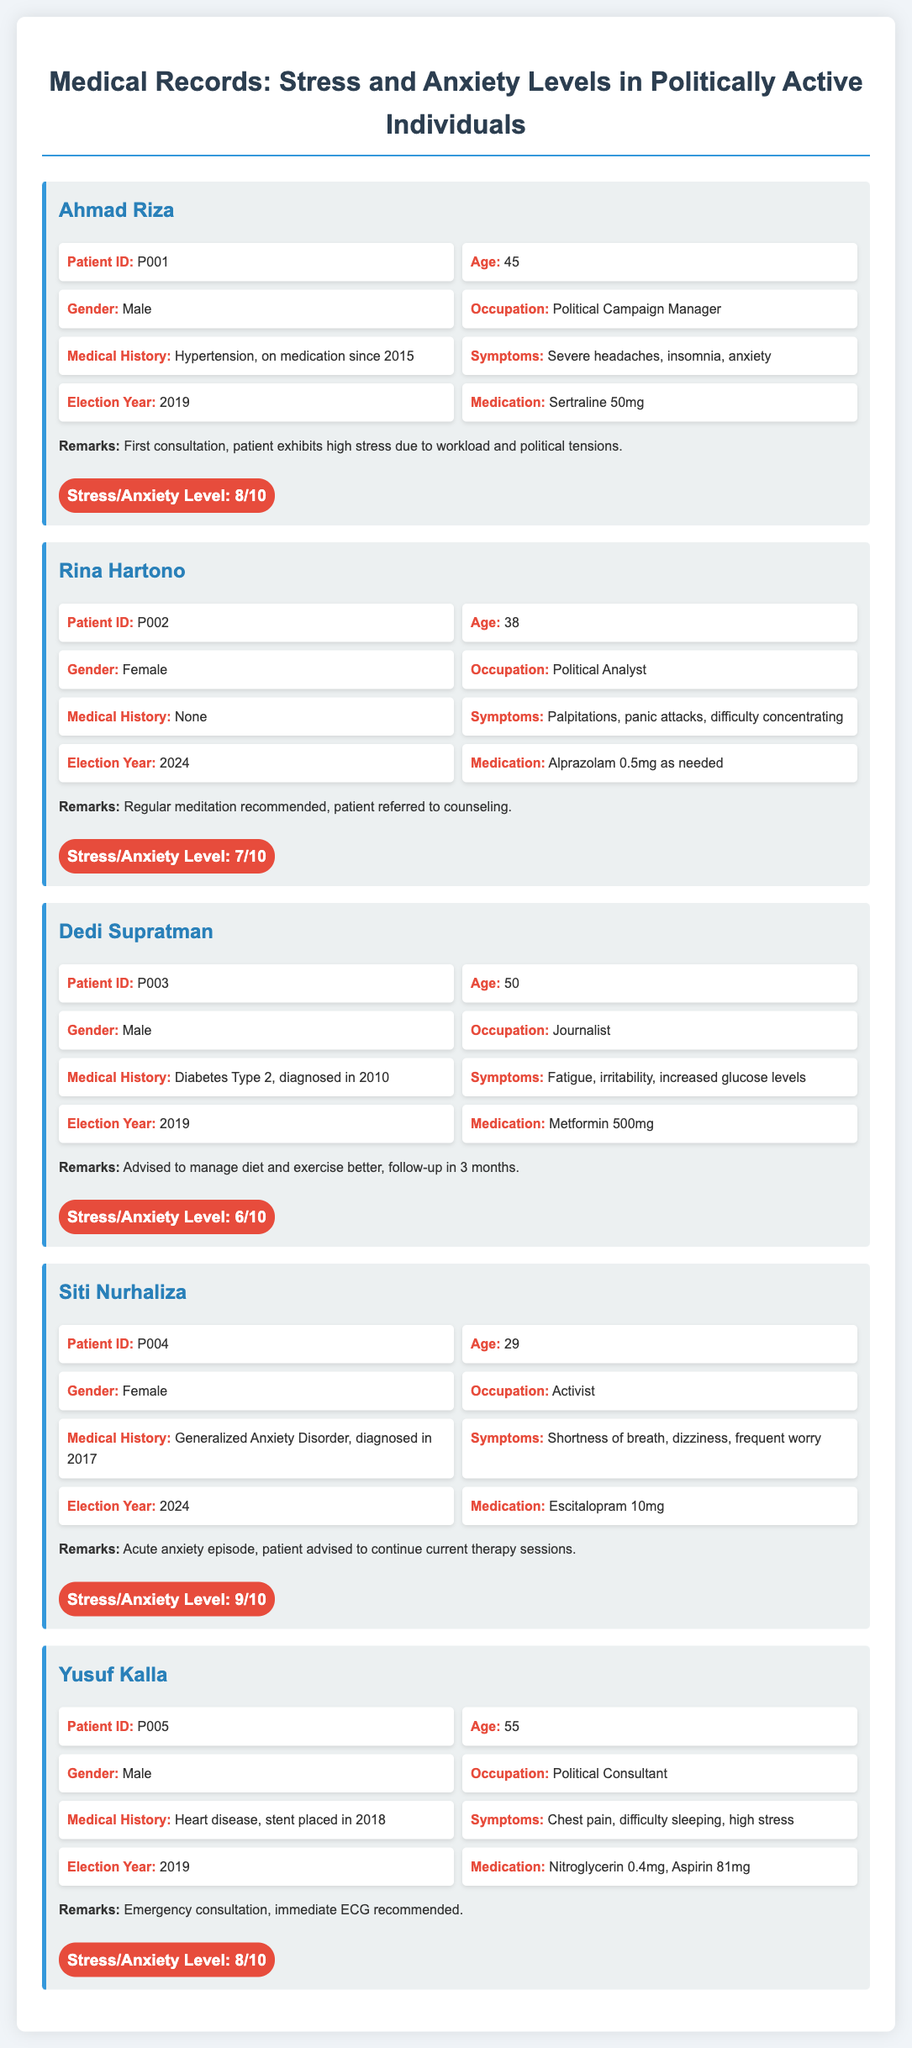What is the age of Ahmad Riza? Ahmad Riza’s age is directly stated in the record as 45 years.
Answer: 45 What medication is Rina Hartono prescribed? The medication prescribed to Rina Hartono is listed in her record as Alprazolam 0.5mg as needed.
Answer: Alprazolam 0.5mg What is the stress/anxiety level of Siti Nurhaliza? Siti Nurhaliza's stress/anxiety level is shown in the record as 9/10.
Answer: 9/10 Which election year does Dedi Supratman’s record correspond to? The record for Dedi Supratman indicates the election year as 2019.
Answer: 2019 What are the symptoms reported by Yusuf Kalla? Yusuf Kalla’s symptoms include chest pain, difficulty sleeping, and high stress, as documented in his medical record.
Answer: Chest pain, difficulty sleeping, high stress How many patients have a stress level of 8 or higher? By reviewing the records, it can be calculated that there are 3 patients with a stress level of 8 or higher.
Answer: 3 What is Siti Nurhaliza’s medical history? Siti Nurhaliza is diagnosed with Generalized Anxiety Disorder, which is noted in her medical record.
Answer: Generalized Anxiety Disorder Why was Rina Hartono referred to counseling? The record states that Rina Hartono was referred to counseling for managing her panic attacks and difficulty concentrating.
Answer: Panic attacks, difficulty concentrating What occupation does Yusuf Kalla have? Yusuf Kalla's occupation is mentioned in the record as a Political Consultant.
Answer: Political Consultant 